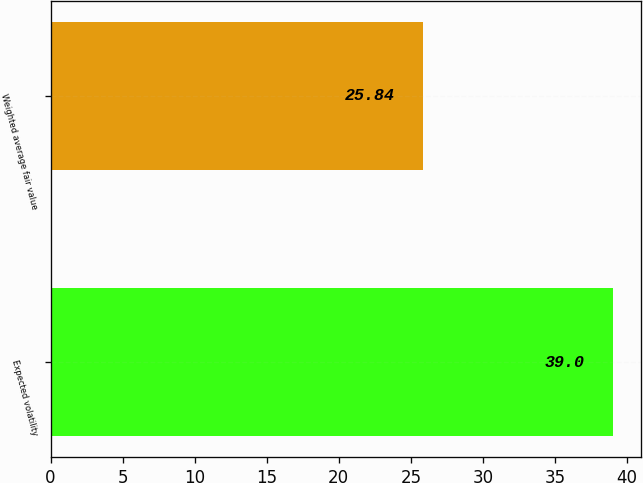Convert chart to OTSL. <chart><loc_0><loc_0><loc_500><loc_500><bar_chart><fcel>Expected volatility<fcel>Weighted average fair value<nl><fcel>39<fcel>25.84<nl></chart> 